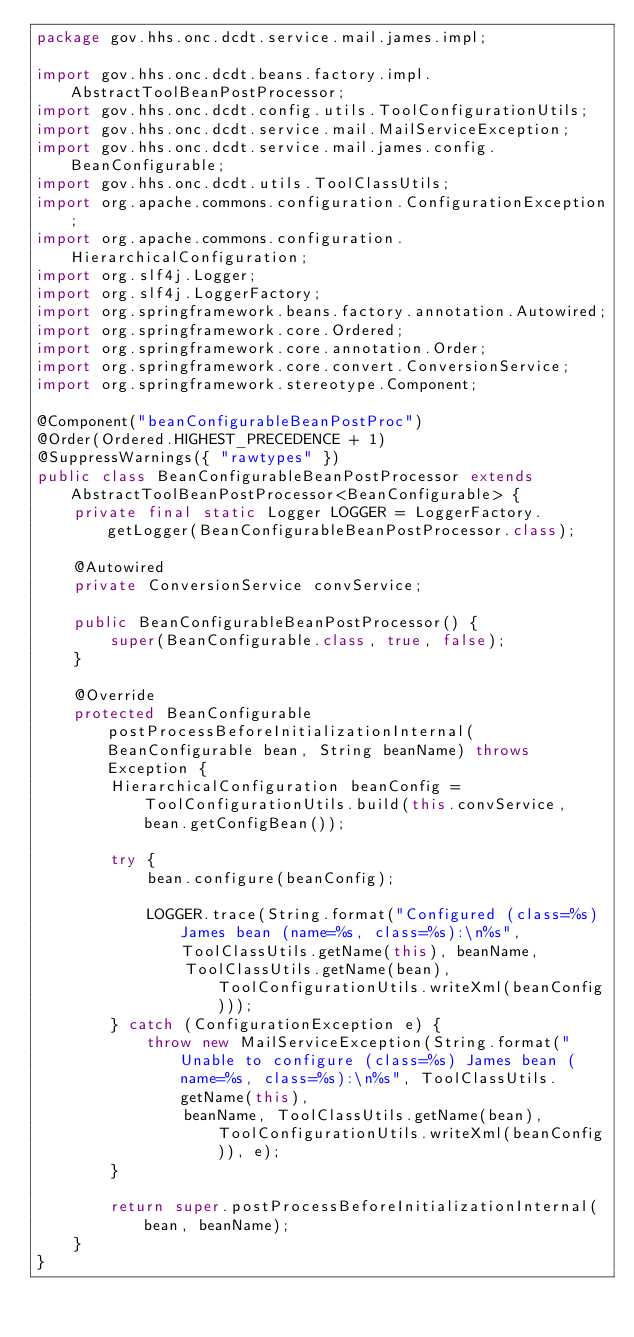Convert code to text. <code><loc_0><loc_0><loc_500><loc_500><_Java_>package gov.hhs.onc.dcdt.service.mail.james.impl;

import gov.hhs.onc.dcdt.beans.factory.impl.AbstractToolBeanPostProcessor;
import gov.hhs.onc.dcdt.config.utils.ToolConfigurationUtils;
import gov.hhs.onc.dcdt.service.mail.MailServiceException;
import gov.hhs.onc.dcdt.service.mail.james.config.BeanConfigurable;
import gov.hhs.onc.dcdt.utils.ToolClassUtils;
import org.apache.commons.configuration.ConfigurationException;
import org.apache.commons.configuration.HierarchicalConfiguration;
import org.slf4j.Logger;
import org.slf4j.LoggerFactory;
import org.springframework.beans.factory.annotation.Autowired;
import org.springframework.core.Ordered;
import org.springframework.core.annotation.Order;
import org.springframework.core.convert.ConversionService;
import org.springframework.stereotype.Component;

@Component("beanConfigurableBeanPostProc")
@Order(Ordered.HIGHEST_PRECEDENCE + 1)
@SuppressWarnings({ "rawtypes" })
public class BeanConfigurableBeanPostProcessor extends AbstractToolBeanPostProcessor<BeanConfigurable> {
    private final static Logger LOGGER = LoggerFactory.getLogger(BeanConfigurableBeanPostProcessor.class);

    @Autowired
    private ConversionService convService;

    public BeanConfigurableBeanPostProcessor() {
        super(BeanConfigurable.class, true, false);
    }

    @Override
    protected BeanConfigurable postProcessBeforeInitializationInternal(BeanConfigurable bean, String beanName) throws Exception {
        HierarchicalConfiguration beanConfig = ToolConfigurationUtils.build(this.convService, bean.getConfigBean());

        try {
            bean.configure(beanConfig);

            LOGGER.trace(String.format("Configured (class=%s) James bean (name=%s, class=%s):\n%s", ToolClassUtils.getName(this), beanName,
                ToolClassUtils.getName(bean), ToolConfigurationUtils.writeXml(beanConfig)));
        } catch (ConfigurationException e) {
            throw new MailServiceException(String.format("Unable to configure (class=%s) James bean (name=%s, class=%s):\n%s", ToolClassUtils.getName(this),
                beanName, ToolClassUtils.getName(bean), ToolConfigurationUtils.writeXml(beanConfig)), e);
        }

        return super.postProcessBeforeInitializationInternal(bean, beanName);
    }
}
</code> 